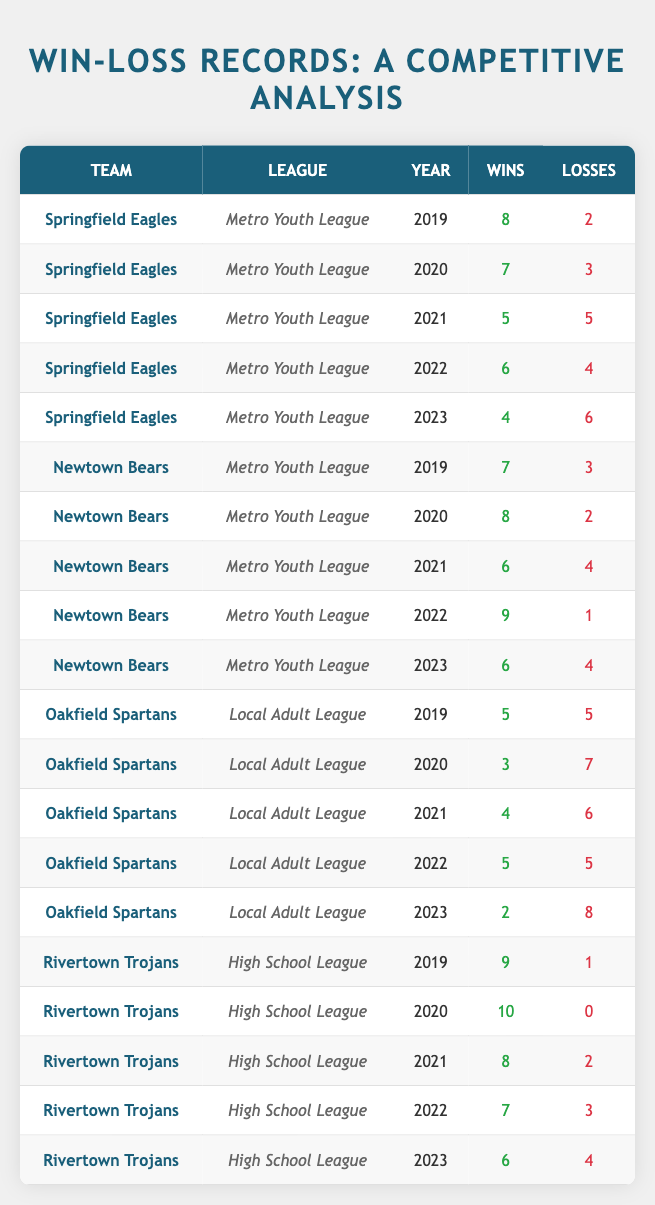What is the total number of wins for the Springfield Eagles over the five years? The wins for Springfield Eagles are as follows: 8 (2019) + 7 (2020) + 5 (2021) + 6 (2022) + 4 (2023) = 30.
Answer: 30 Which team had the highest number of wins in a single year? The Newtown Bears had the highest number of wins in 2022 with 9 wins.
Answer: Newtown Bears What was the win-loss ratio of the Rivertown Trojans in 2020? The Rivertown Trojans won 10 games and lost none in 2020, so the win-loss ratio is 10:0, which is considered 10.
Answer: 10:0 Did any team have more wins than losses in every year from 2019 to 2023? Checking the teams, Newtown Bears had more wins than losses in 2019 (7-3), 2020 (8-2), and 2022 (9-1), but in 2021 they had 6 wins and 4 losses, so the answer is no.
Answer: No What is the average number of losses for the Oakfield Spartans over the five years? The losses for Oakfield Spartans are 5 (2019) + 7 (2020) + 6 (2021) + 5 (2022) + 8 (2023) = 31 total losses. Dividing by 5 years gives an average of 31/5 = 6.2.
Answer: 6.2 Which team experienced the most significant decrease in wins from 2019 to 2023? Springfield Eagles had 8 wins in 2019 and 4 in 2023, a decrease of 4 wins. Comparatively, Newtown Bears decreased by 2 wins, and Oakfield Spartans decreased by 3 wins.
Answer: Springfield Eagles How many total losses did all teams combined have in 2021? Adding the losses for all teams in 2021 gives: Springfield Eagles (5) + Newtown Bears (4) + Oakfield Spartans (6) + Rivertown Trojans (2) = 17 total losses.
Answer: 17 What percentage of the Newtown Bears' wins in 2022 contributed to their total wins over the five years? In 2022, Newtown Bears won 9 games. Their total wins from 2019 to 2023 was 38 (7+8+6+9+6). The percentage is (9/38) * 100 = 23.68%.
Answer: 23.68% Which league had the lowest average number of total wins per team based on the data provided? Calculating the averages: Metro Youth League total wins =  8+7+5+6+4 +7+8+6+9+6 = 66/10 = 6.6. Local Adult League total = 5+3+4+5+2 = 19/5 = 3.8. High School League total = 9+10+8+7+6 = 40/5 = 8. The Local Adult League had the lowest average.
Answer: Local Adult League What pattern can be observed regarding the performance of the Rivertown Trojans from 2019 to 2023? Analyzing Rivertown Trojans: they had consistent performance with the highest wins in 2020 (10), only decreasing in the following years but still performing well above average overall, indicating strong historical performance despite some decline.
Answer: Generally consistent strong performance 